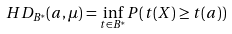Convert formula to latex. <formula><loc_0><loc_0><loc_500><loc_500>H D _ { B ^ { * } } ( a , \mu ) = \inf _ { t \in B ^ { * } } P ( t ( X ) \geq t ( a ) )</formula> 